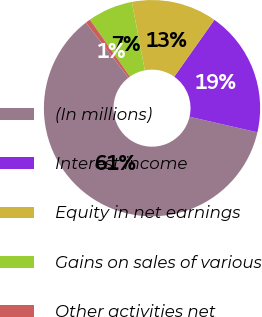Convert chart. <chart><loc_0><loc_0><loc_500><loc_500><pie_chart><fcel>(In millions)<fcel>Interest income<fcel>Equity in net earnings<fcel>Gains on sales of various<fcel>Other activities net<nl><fcel>60.95%<fcel>18.8%<fcel>12.77%<fcel>6.75%<fcel>0.73%<nl></chart> 